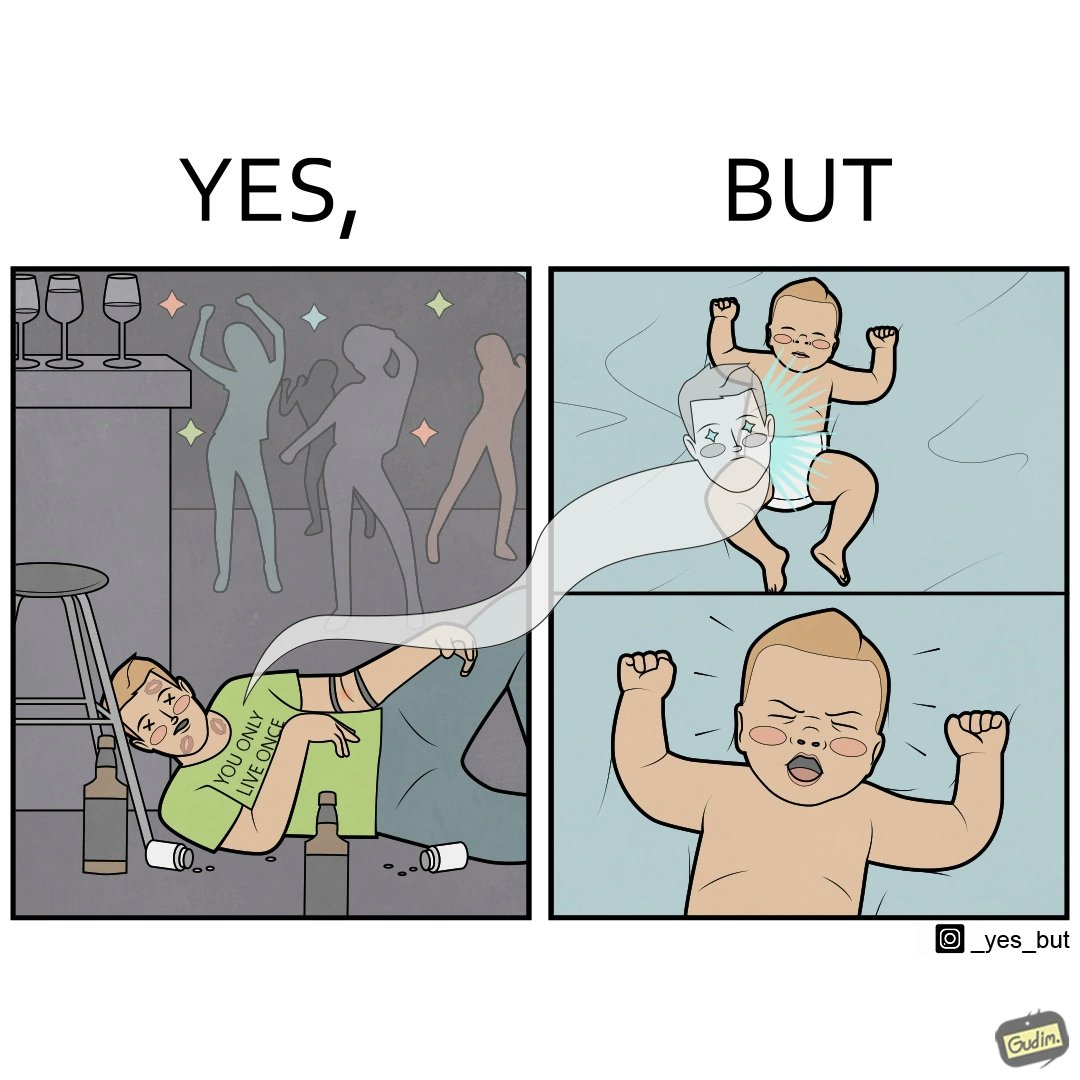What does this image depict? The image is ironical, as the person is believes that "You Only Live Once" (as can be seen from the t-shirt), and hence drinks and parties a lot, and is dead probably due to drug overdose. However, it is shown that the person re-incarnates as a crying baby, which goes against the person's belief. 